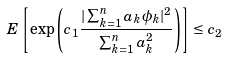Convert formula to latex. <formula><loc_0><loc_0><loc_500><loc_500>{ E } \left [ \exp \left ( c _ { 1 } \frac { | \sum _ { k = 1 } ^ { n } a _ { k } \phi _ { k } | ^ { 2 } } { \sum _ { k = 1 } ^ { n } a _ { k } ^ { 2 } } \right ) \right ] \leq c _ { 2 }</formula> 